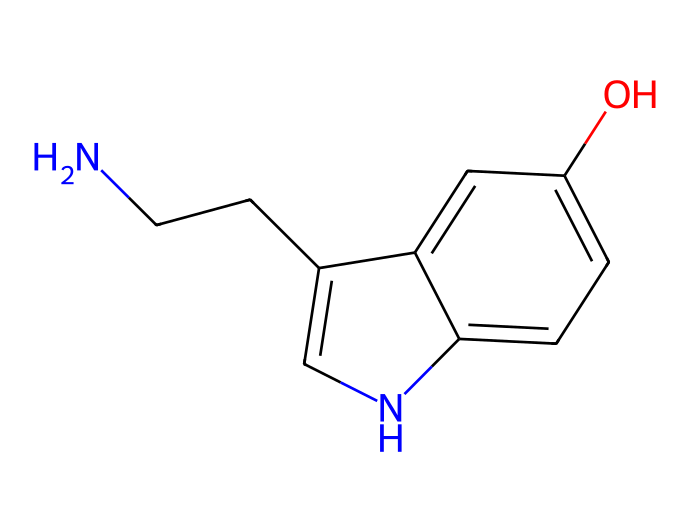What is the molecular formula of serotonin? To find the molecular formula, count the number of each type of atom in the SMILES representation. There are 10 carbon atoms (C), 12 hydrogen atoms (H), 2 nitrogen atoms (N), and 1 oxygen atom (O). This gives the formula C10H12N2O.
Answer: C10H12N2O How many nitrogen atoms are in serotonin? By inspecting the SMILES code, notice the presence of nitrogen atoms represented by the letter 'N.' There are 2 'N' in the provided representation.
Answer: 2 What type of functional group is present in serotonin? In the structure, there is a hydroxyl group (-OH) attached to the aromatic ring, which indicates the presence of an alcohol functional group.
Answer: alcohol What type of aromatic structure is part of serotonin? The chemical structure includes a six-membered benzene ring, as shown in the cyclic portion of the SMILES, which contributes to its aromatic character.
Answer: benzene What is the significance of the nitrogen atoms in serotonin? The nitrogen atoms in serotonin are part of the amine functional groups, which are crucial for its role as a neurotransmitter in the brain, affecting mood and cognition.
Answer: neurotransmitter How many rings are present in the structure of serotonin? Examining the SMILES, you will identify one five-membered ring and one six-membered ring, thus the total is two rings in the structure.
Answer: 2 What makes serotonin an aliphatic compound? While serotonin contains an aromatic portion, it also has an aliphatic chain due to the presence of the carbon atoms directly attached to the nitrogen atoms. Aliphatic compounds can contain both aliphatic and cyclic structures.
Answer: aliphatic and cyclic 